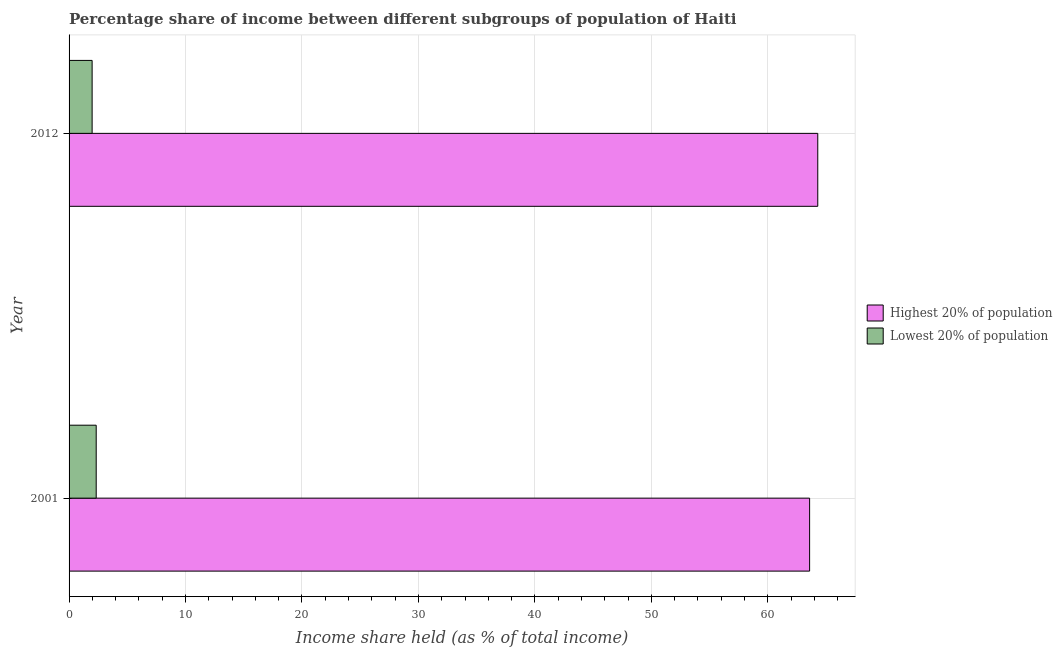How many groups of bars are there?
Give a very brief answer. 2. Are the number of bars per tick equal to the number of legend labels?
Give a very brief answer. Yes. How many bars are there on the 1st tick from the bottom?
Offer a terse response. 2. In how many cases, is the number of bars for a given year not equal to the number of legend labels?
Provide a succinct answer. 0. What is the income share held by highest 20% of the population in 2012?
Keep it short and to the point. 64.29. Across all years, what is the maximum income share held by lowest 20% of the population?
Offer a terse response. 2.33. Across all years, what is the minimum income share held by lowest 20% of the population?
Your response must be concise. 1.98. In which year was the income share held by lowest 20% of the population minimum?
Your answer should be compact. 2012. What is the total income share held by lowest 20% of the population in the graph?
Your response must be concise. 4.31. What is the difference between the income share held by lowest 20% of the population in 2012 and the income share held by highest 20% of the population in 2001?
Make the answer very short. -61.61. What is the average income share held by highest 20% of the population per year?
Offer a very short reply. 63.94. In the year 2001, what is the difference between the income share held by lowest 20% of the population and income share held by highest 20% of the population?
Your answer should be very brief. -61.26. In how many years, is the income share held by highest 20% of the population greater than 12 %?
Keep it short and to the point. 2. What is the ratio of the income share held by highest 20% of the population in 2001 to that in 2012?
Offer a very short reply. 0.99. Is the income share held by lowest 20% of the population in 2001 less than that in 2012?
Provide a short and direct response. No. In how many years, is the income share held by highest 20% of the population greater than the average income share held by highest 20% of the population taken over all years?
Make the answer very short. 1. What does the 2nd bar from the top in 2001 represents?
Offer a terse response. Highest 20% of population. What does the 1st bar from the bottom in 2001 represents?
Offer a very short reply. Highest 20% of population. Are all the bars in the graph horizontal?
Keep it short and to the point. Yes. How many years are there in the graph?
Make the answer very short. 2. Does the graph contain grids?
Provide a succinct answer. Yes. Where does the legend appear in the graph?
Provide a succinct answer. Center right. How many legend labels are there?
Ensure brevity in your answer.  2. How are the legend labels stacked?
Give a very brief answer. Vertical. What is the title of the graph?
Your answer should be compact. Percentage share of income between different subgroups of population of Haiti. What is the label or title of the X-axis?
Ensure brevity in your answer.  Income share held (as % of total income). What is the label or title of the Y-axis?
Give a very brief answer. Year. What is the Income share held (as % of total income) of Highest 20% of population in 2001?
Your response must be concise. 63.59. What is the Income share held (as % of total income) of Lowest 20% of population in 2001?
Ensure brevity in your answer.  2.33. What is the Income share held (as % of total income) of Highest 20% of population in 2012?
Provide a short and direct response. 64.29. What is the Income share held (as % of total income) in Lowest 20% of population in 2012?
Give a very brief answer. 1.98. Across all years, what is the maximum Income share held (as % of total income) in Highest 20% of population?
Offer a very short reply. 64.29. Across all years, what is the maximum Income share held (as % of total income) of Lowest 20% of population?
Your response must be concise. 2.33. Across all years, what is the minimum Income share held (as % of total income) in Highest 20% of population?
Offer a terse response. 63.59. Across all years, what is the minimum Income share held (as % of total income) of Lowest 20% of population?
Your answer should be very brief. 1.98. What is the total Income share held (as % of total income) in Highest 20% of population in the graph?
Give a very brief answer. 127.88. What is the total Income share held (as % of total income) in Lowest 20% of population in the graph?
Ensure brevity in your answer.  4.31. What is the difference between the Income share held (as % of total income) of Highest 20% of population in 2001 and that in 2012?
Keep it short and to the point. -0.7. What is the difference between the Income share held (as % of total income) in Lowest 20% of population in 2001 and that in 2012?
Give a very brief answer. 0.35. What is the difference between the Income share held (as % of total income) in Highest 20% of population in 2001 and the Income share held (as % of total income) in Lowest 20% of population in 2012?
Ensure brevity in your answer.  61.61. What is the average Income share held (as % of total income) in Highest 20% of population per year?
Keep it short and to the point. 63.94. What is the average Income share held (as % of total income) of Lowest 20% of population per year?
Make the answer very short. 2.15. In the year 2001, what is the difference between the Income share held (as % of total income) in Highest 20% of population and Income share held (as % of total income) in Lowest 20% of population?
Give a very brief answer. 61.26. In the year 2012, what is the difference between the Income share held (as % of total income) in Highest 20% of population and Income share held (as % of total income) in Lowest 20% of population?
Offer a terse response. 62.31. What is the ratio of the Income share held (as % of total income) in Highest 20% of population in 2001 to that in 2012?
Your answer should be very brief. 0.99. What is the ratio of the Income share held (as % of total income) in Lowest 20% of population in 2001 to that in 2012?
Provide a short and direct response. 1.18. What is the difference between the highest and the second highest Income share held (as % of total income) in Highest 20% of population?
Provide a short and direct response. 0.7. What is the difference between the highest and the lowest Income share held (as % of total income) in Lowest 20% of population?
Your answer should be compact. 0.35. 